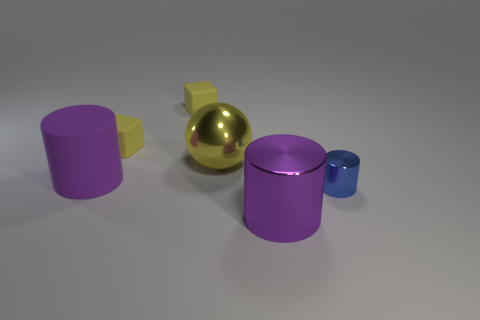Add 2 big yellow metal things. How many objects exist? 8 Subtract all blocks. How many objects are left? 4 Add 2 blue cylinders. How many blue cylinders exist? 3 Subtract 0 gray cylinders. How many objects are left? 6 Subtract all big balls. Subtract all big purple metal cylinders. How many objects are left? 4 Add 3 yellow rubber things. How many yellow rubber things are left? 5 